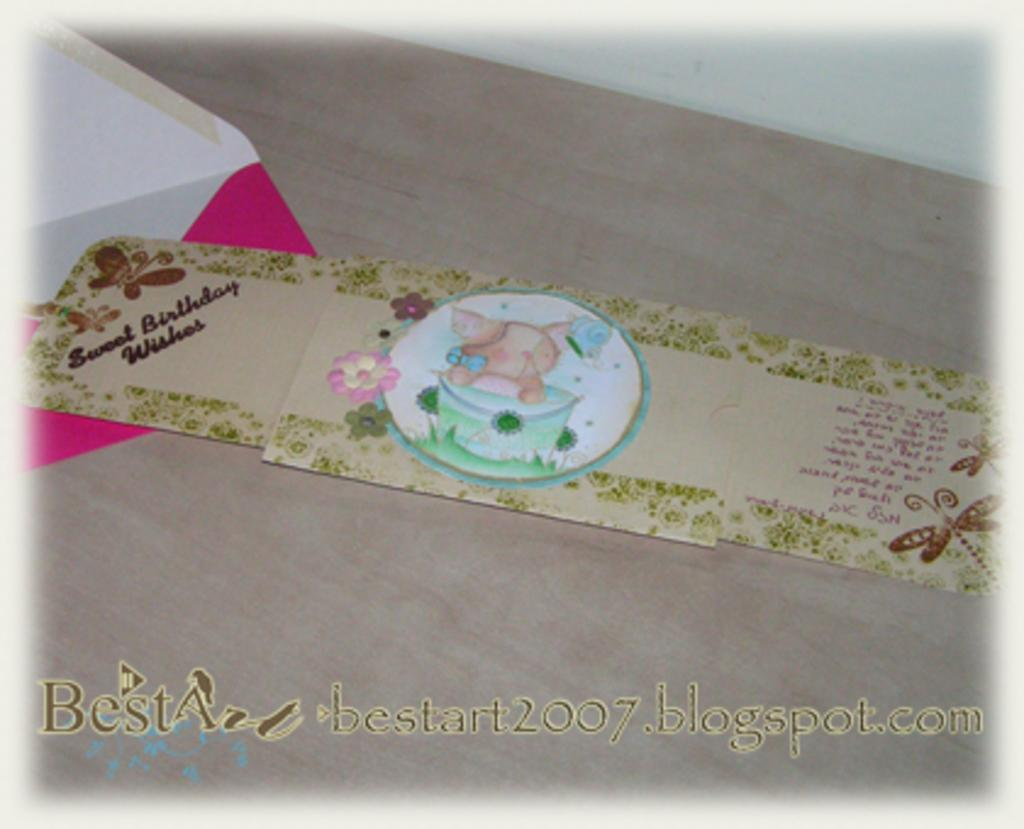<image>
Write a terse but informative summary of the picture. A thre panel card with drawing of a cat on birthday cake offering Sweet Birthday Wishes. 